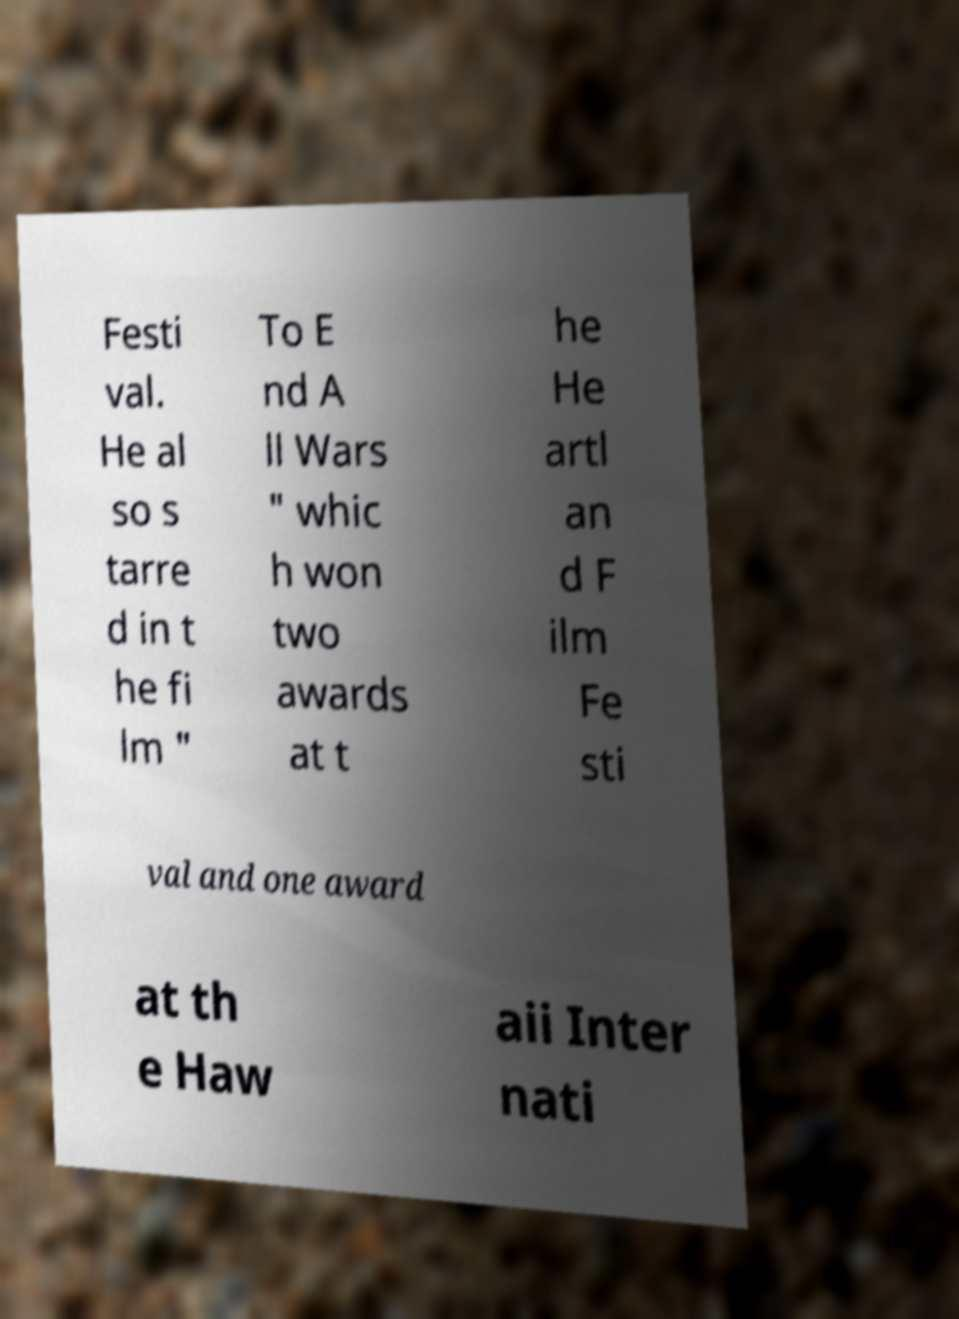There's text embedded in this image that I need extracted. Can you transcribe it verbatim? Festi val. He al so s tarre d in t he fi lm " To E nd A ll Wars " whic h won two awards at t he He artl an d F ilm Fe sti val and one award at th e Haw aii Inter nati 